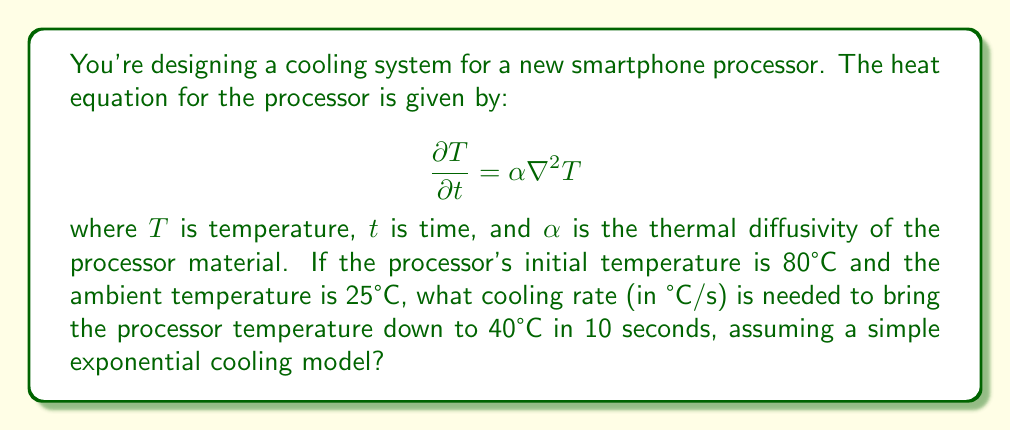Show me your answer to this math problem. Let's approach this step-by-step:

1) For simple exponential cooling, we can use the solution to the heat equation in the form:

   $$T(t) = T_a + (T_0 - T_a)e^{-kt}$$

   where $T(t)$ is the temperature at time $t$, $T_a$ is the ambient temperature, $T_0$ is the initial temperature, and $k$ is the cooling rate.

2) We're given:
   $T_0 = 80°C$
   $T_a = 25°C$
   $T(10) = 40°C$ (final temperature after 10 seconds)
   $t = 10$ seconds

3) Let's substitute these into our equation:

   $$40 = 25 + (80 - 25)e^{-k(10)}$$

4) Simplify:
   $$15 = 55e^{-10k}$$

5) Divide both sides by 55:
   $$\frac{15}{55} = e^{-10k}$$

6) Take the natural log of both sides:
   $$\ln(\frac{15}{55}) = -10k$$

7) Solve for $k$:
   $$k = -\frac{1}{10}\ln(\frac{15}{55}) \approx 0.1301$$

8) This $k$ value represents the cooling rate in s^-1. To convert to °C/s, we multiply by the initial temperature difference:

   Cooling rate = $k(T_0 - T_a) = 0.1301(80 - 25) \approx 7.16$ °C/s
Answer: 7.16 °C/s 